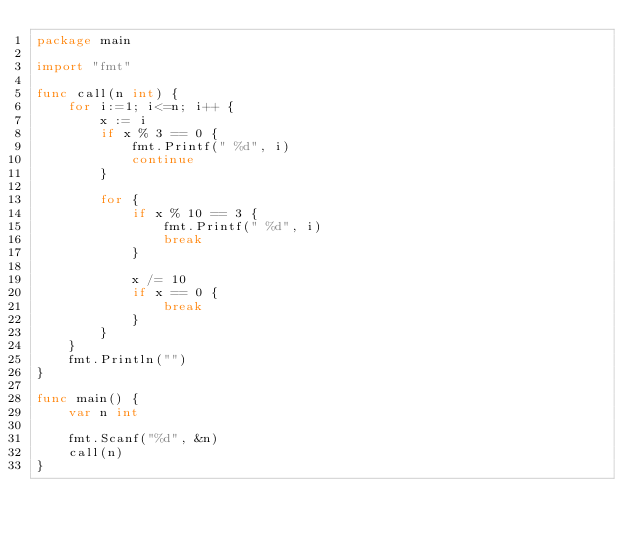Convert code to text. <code><loc_0><loc_0><loc_500><loc_500><_Go_>package main

import "fmt"

func call(n int) {
    for i:=1; i<=n; i++ {
        x := i
        if x % 3 == 0 {
            fmt.Printf(" %d", i)
            continue
        }

        for {
            if x % 10 == 3 {
                fmt.Printf(" %d", i)
                break
            }

            x /= 10
            if x == 0 {
                break
            }
        }
    }
    fmt.Println("")
}

func main() {
    var n int

    fmt.Scanf("%d", &n)
    call(n)
}
</code> 